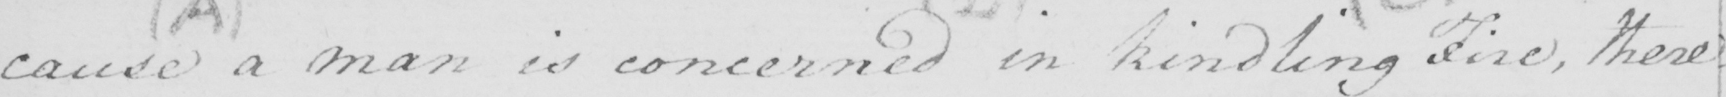Can you tell me what this handwritten text says? cause a man is concerned in kindling fire , there= 